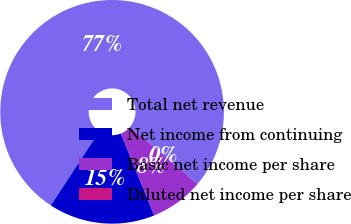Convert chart. <chart><loc_0><loc_0><loc_500><loc_500><pie_chart><fcel>Total net revenue<fcel>Net income from continuing<fcel>Basic net income per share<fcel>Diluted net income per share<nl><fcel>76.92%<fcel>15.38%<fcel>7.69%<fcel>0.0%<nl></chart> 